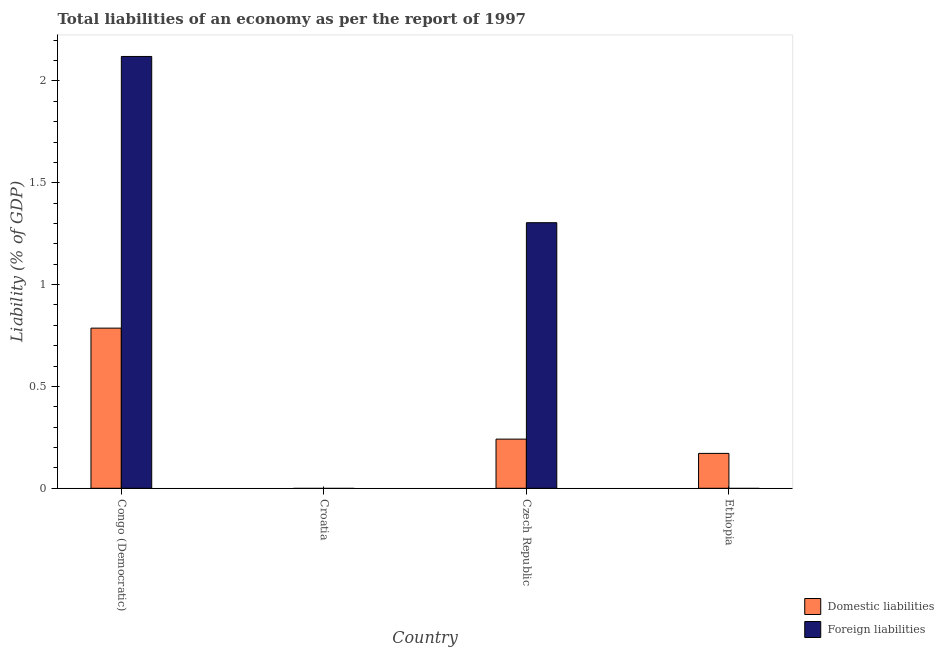Are the number of bars per tick equal to the number of legend labels?
Offer a very short reply. No. What is the label of the 3rd group of bars from the left?
Your response must be concise. Czech Republic. Across all countries, what is the maximum incurrence of domestic liabilities?
Offer a very short reply. 0.79. In which country was the incurrence of foreign liabilities maximum?
Offer a very short reply. Congo (Democratic). What is the total incurrence of foreign liabilities in the graph?
Offer a terse response. 3.42. What is the difference between the incurrence of domestic liabilities in Congo (Democratic) and that in Ethiopia?
Your answer should be compact. 0.62. What is the difference between the incurrence of domestic liabilities in Czech Republic and the incurrence of foreign liabilities in Ethiopia?
Offer a very short reply. 0.24. What is the average incurrence of domestic liabilities per country?
Keep it short and to the point. 0.3. What is the difference between the incurrence of foreign liabilities and incurrence of domestic liabilities in Czech Republic?
Give a very brief answer. 1.06. In how many countries, is the incurrence of foreign liabilities greater than 1.4 %?
Your answer should be very brief. 1. What is the ratio of the incurrence of domestic liabilities in Czech Republic to that in Ethiopia?
Provide a succinct answer. 1.41. Is the incurrence of foreign liabilities in Congo (Democratic) less than that in Czech Republic?
Offer a terse response. No. What is the difference between the highest and the second highest incurrence of domestic liabilities?
Offer a terse response. 0.54. What is the difference between the highest and the lowest incurrence of foreign liabilities?
Ensure brevity in your answer.  2.12. How many bars are there?
Offer a terse response. 5. Are all the bars in the graph horizontal?
Ensure brevity in your answer.  No. How many countries are there in the graph?
Make the answer very short. 4. Are the values on the major ticks of Y-axis written in scientific E-notation?
Provide a short and direct response. No. Does the graph contain any zero values?
Provide a succinct answer. Yes. Does the graph contain grids?
Give a very brief answer. No. Where does the legend appear in the graph?
Make the answer very short. Bottom right. How are the legend labels stacked?
Provide a short and direct response. Vertical. What is the title of the graph?
Offer a very short reply. Total liabilities of an economy as per the report of 1997. Does "Merchandise exports" appear as one of the legend labels in the graph?
Provide a short and direct response. No. What is the label or title of the X-axis?
Keep it short and to the point. Country. What is the label or title of the Y-axis?
Ensure brevity in your answer.  Liability (% of GDP). What is the Liability (% of GDP) in Domestic liabilities in Congo (Democratic)?
Make the answer very short. 0.79. What is the Liability (% of GDP) of Foreign liabilities in Congo (Democratic)?
Provide a short and direct response. 2.12. What is the Liability (% of GDP) in Domestic liabilities in Croatia?
Your answer should be compact. 0. What is the Liability (% of GDP) of Foreign liabilities in Croatia?
Offer a very short reply. 0. What is the Liability (% of GDP) of Domestic liabilities in Czech Republic?
Ensure brevity in your answer.  0.24. What is the Liability (% of GDP) of Foreign liabilities in Czech Republic?
Your answer should be compact. 1.3. What is the Liability (% of GDP) in Domestic liabilities in Ethiopia?
Offer a terse response. 0.17. What is the Liability (% of GDP) of Foreign liabilities in Ethiopia?
Your response must be concise. 0. Across all countries, what is the maximum Liability (% of GDP) of Domestic liabilities?
Give a very brief answer. 0.79. Across all countries, what is the maximum Liability (% of GDP) in Foreign liabilities?
Give a very brief answer. 2.12. What is the total Liability (% of GDP) of Domestic liabilities in the graph?
Your answer should be compact. 1.2. What is the total Liability (% of GDP) of Foreign liabilities in the graph?
Give a very brief answer. 3.42. What is the difference between the Liability (% of GDP) of Domestic liabilities in Congo (Democratic) and that in Czech Republic?
Offer a very short reply. 0.54. What is the difference between the Liability (% of GDP) of Foreign liabilities in Congo (Democratic) and that in Czech Republic?
Keep it short and to the point. 0.82. What is the difference between the Liability (% of GDP) of Domestic liabilities in Congo (Democratic) and that in Ethiopia?
Offer a very short reply. 0.62. What is the difference between the Liability (% of GDP) in Domestic liabilities in Czech Republic and that in Ethiopia?
Your answer should be compact. 0.07. What is the difference between the Liability (% of GDP) of Domestic liabilities in Congo (Democratic) and the Liability (% of GDP) of Foreign liabilities in Czech Republic?
Your response must be concise. -0.52. What is the average Liability (% of GDP) in Domestic liabilities per country?
Your response must be concise. 0.3. What is the average Liability (% of GDP) of Foreign liabilities per country?
Give a very brief answer. 0.86. What is the difference between the Liability (% of GDP) of Domestic liabilities and Liability (% of GDP) of Foreign liabilities in Congo (Democratic)?
Provide a succinct answer. -1.33. What is the difference between the Liability (% of GDP) of Domestic liabilities and Liability (% of GDP) of Foreign liabilities in Czech Republic?
Provide a short and direct response. -1.06. What is the ratio of the Liability (% of GDP) of Domestic liabilities in Congo (Democratic) to that in Czech Republic?
Ensure brevity in your answer.  3.26. What is the ratio of the Liability (% of GDP) of Foreign liabilities in Congo (Democratic) to that in Czech Republic?
Offer a very short reply. 1.63. What is the ratio of the Liability (% of GDP) in Domestic liabilities in Congo (Democratic) to that in Ethiopia?
Offer a very short reply. 4.59. What is the ratio of the Liability (% of GDP) in Domestic liabilities in Czech Republic to that in Ethiopia?
Keep it short and to the point. 1.41. What is the difference between the highest and the second highest Liability (% of GDP) in Domestic liabilities?
Provide a succinct answer. 0.54. What is the difference between the highest and the lowest Liability (% of GDP) of Domestic liabilities?
Offer a very short reply. 0.79. What is the difference between the highest and the lowest Liability (% of GDP) in Foreign liabilities?
Provide a short and direct response. 2.12. 